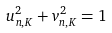Convert formula to latex. <formula><loc_0><loc_0><loc_500><loc_500>u _ { n , K } ^ { 2 } + v _ { n , K } ^ { 2 } = 1</formula> 